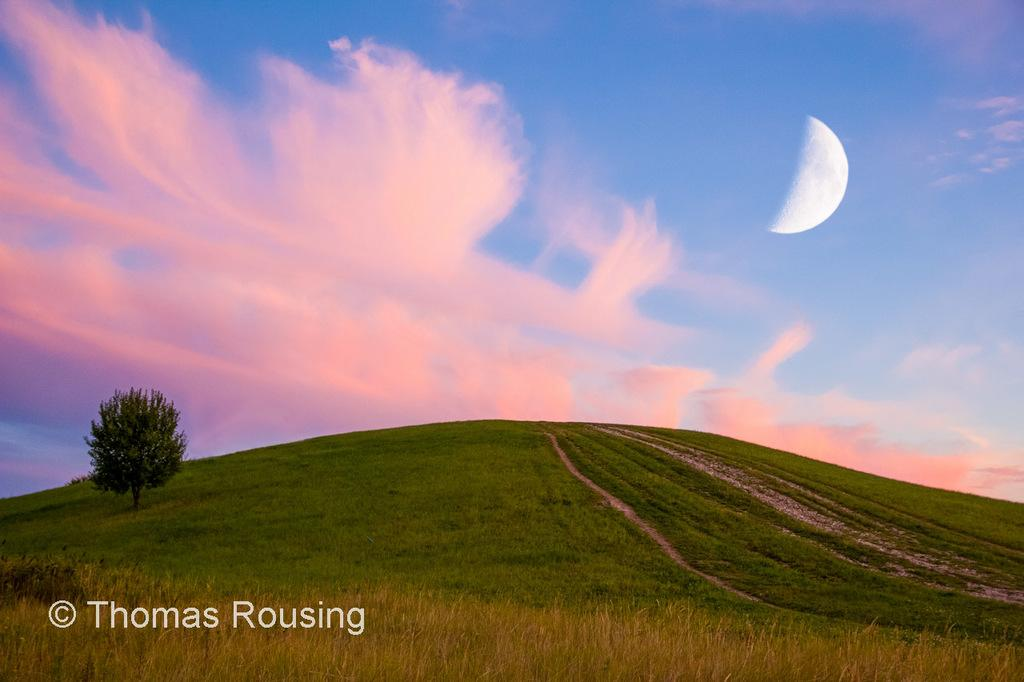What type of vegetation can be seen in the image? There is grass in the image. What other natural element is present in the image? There is a tree in the image. What is visible at the top of the image? The sky is visible at the top of the image. What celestial body can be seen in the sky? The moon is present in the sky. What type of jeans is hanging on the tree in the image? There are no jeans present in the image; it features grass, a tree, and the sky. What type of garden can be seen in the image? The image does not depict a garden; it shows grass, a tree, and the sky. 